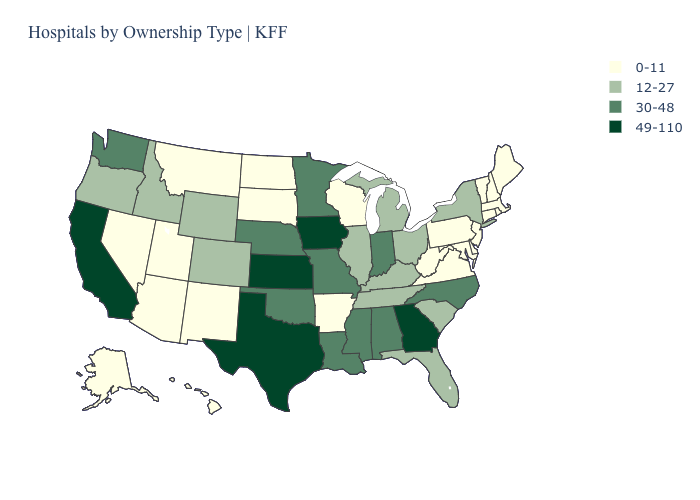Does Ohio have the same value as Oregon?
Give a very brief answer. Yes. What is the value of Delaware?
Give a very brief answer. 0-11. Does South Carolina have a lower value than Montana?
Be succinct. No. Does the first symbol in the legend represent the smallest category?
Be succinct. Yes. Name the states that have a value in the range 12-27?
Give a very brief answer. Colorado, Florida, Idaho, Illinois, Kentucky, Michigan, New York, Ohio, Oregon, South Carolina, Tennessee, Wyoming. Which states have the highest value in the USA?
Concise answer only. California, Georgia, Iowa, Kansas, Texas. Does New Jersey have the same value as Indiana?
Quick response, please. No. Which states hav the highest value in the MidWest?
Write a very short answer. Iowa, Kansas. Which states hav the highest value in the South?
Give a very brief answer. Georgia, Texas. Name the states that have a value in the range 30-48?
Answer briefly. Alabama, Indiana, Louisiana, Minnesota, Mississippi, Missouri, Nebraska, North Carolina, Oklahoma, Washington. Among the states that border California , which have the lowest value?
Be succinct. Arizona, Nevada. What is the value of Minnesota?
Short answer required. 30-48. Among the states that border Pennsylvania , which have the highest value?
Write a very short answer. New York, Ohio. Which states have the lowest value in the USA?
Write a very short answer. Alaska, Arizona, Arkansas, Connecticut, Delaware, Hawaii, Maine, Maryland, Massachusetts, Montana, Nevada, New Hampshire, New Jersey, New Mexico, North Dakota, Pennsylvania, Rhode Island, South Dakota, Utah, Vermont, Virginia, West Virginia, Wisconsin. What is the value of Alabama?
Write a very short answer. 30-48. 